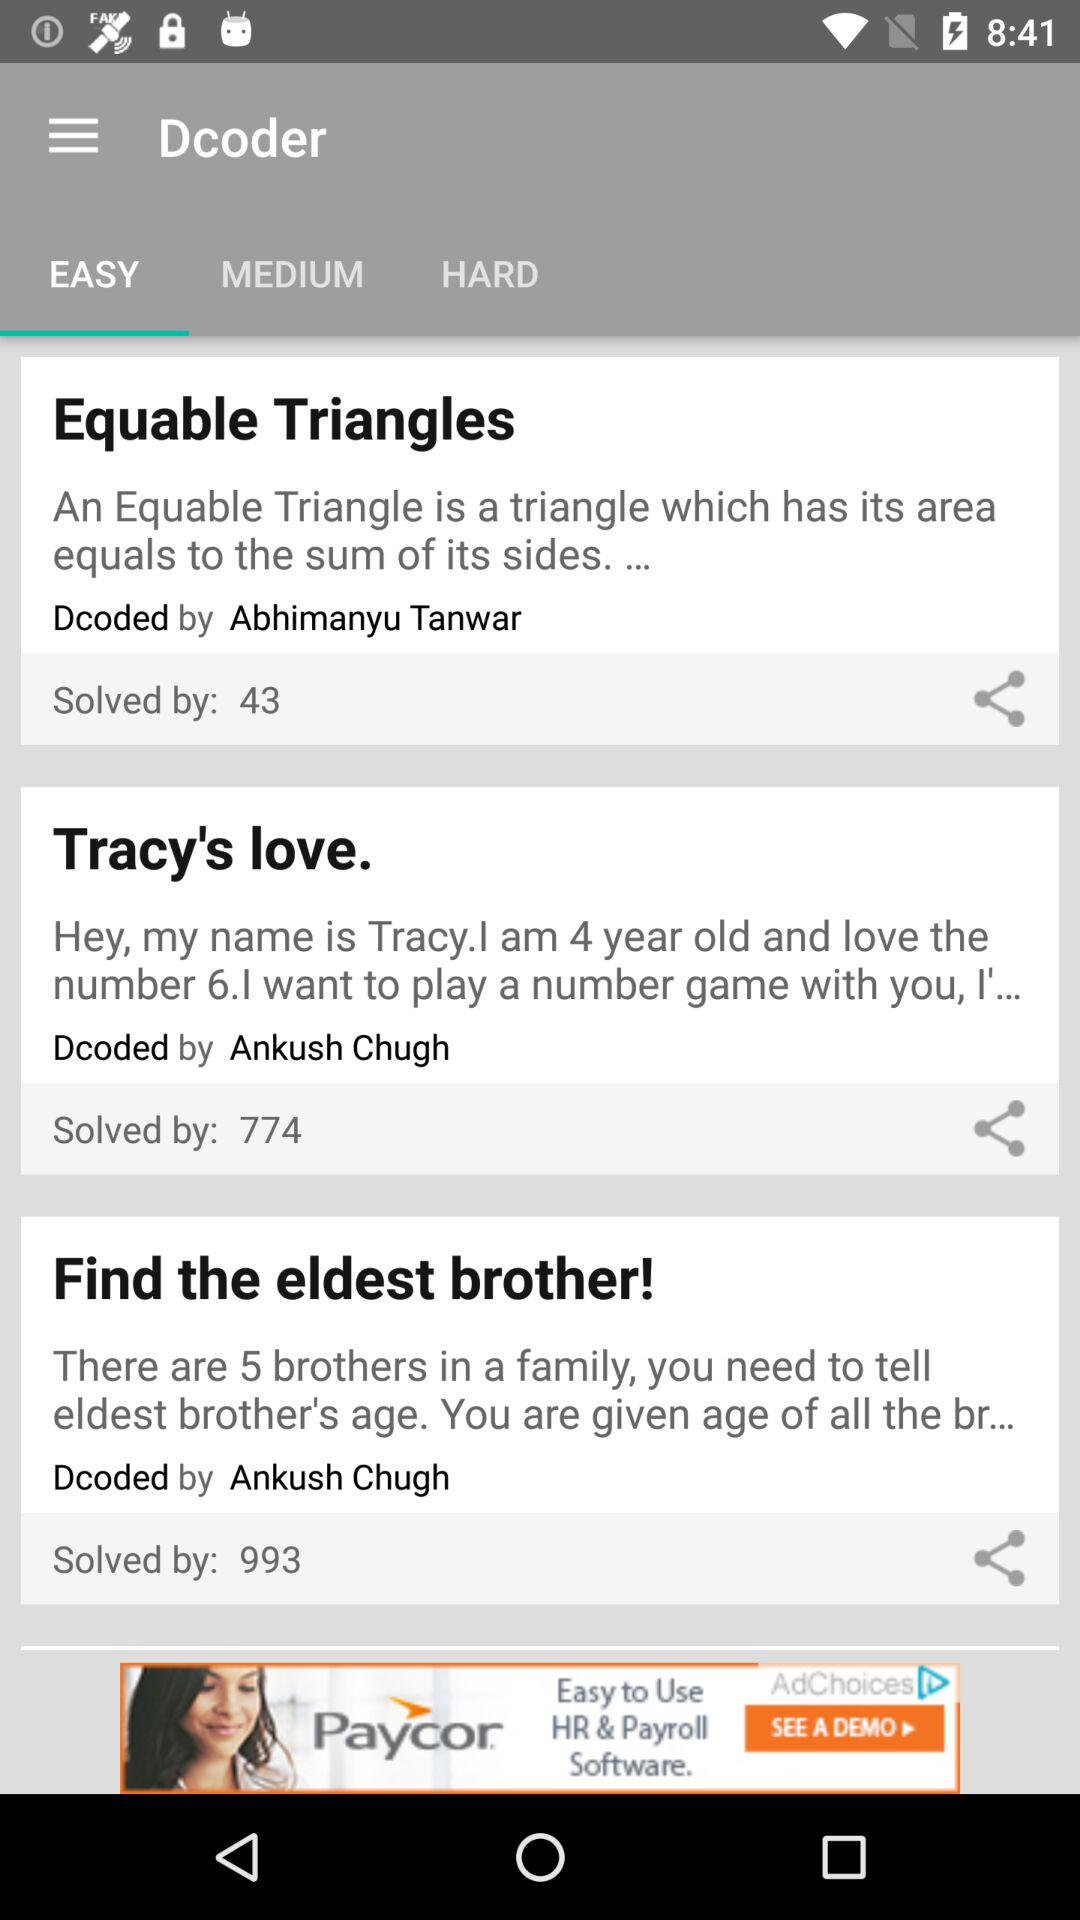What is the name of the decoder for "Equable Triangles"? The name of the decoder for "Equable Triangles" is Abhimanyu Tanwar. 